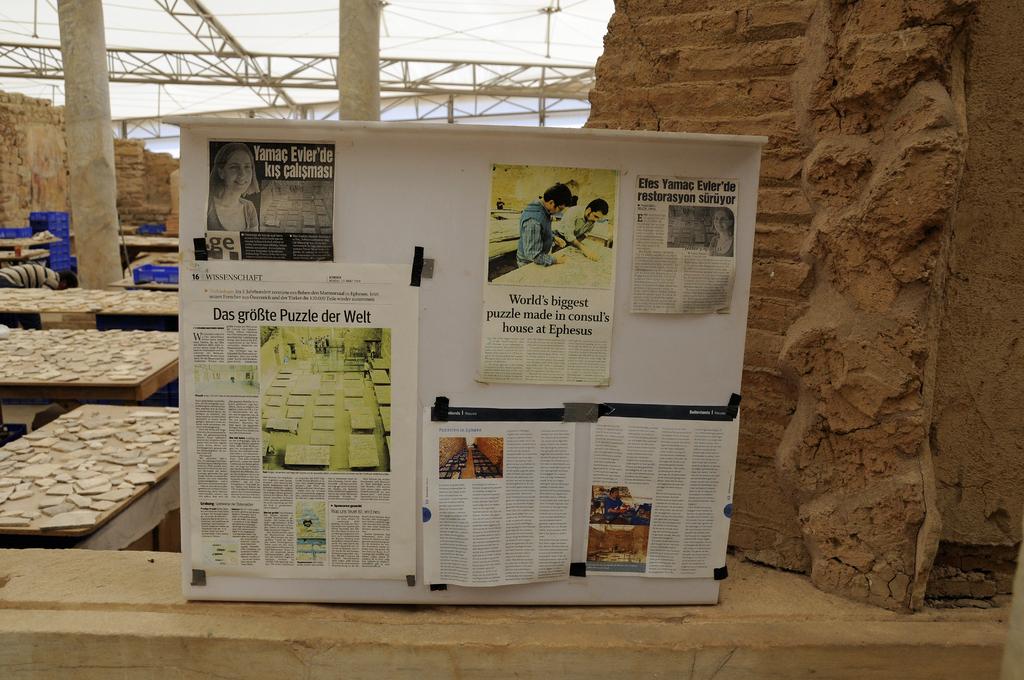What is the top center poster about?
Keep it short and to the point. Unanswerable. 